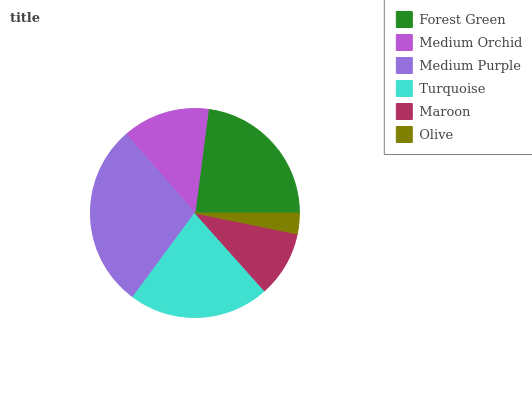Is Olive the minimum?
Answer yes or no. Yes. Is Medium Purple the maximum?
Answer yes or no. Yes. Is Medium Orchid the minimum?
Answer yes or no. No. Is Medium Orchid the maximum?
Answer yes or no. No. Is Forest Green greater than Medium Orchid?
Answer yes or no. Yes. Is Medium Orchid less than Forest Green?
Answer yes or no. Yes. Is Medium Orchid greater than Forest Green?
Answer yes or no. No. Is Forest Green less than Medium Orchid?
Answer yes or no. No. Is Turquoise the high median?
Answer yes or no. Yes. Is Medium Orchid the low median?
Answer yes or no. Yes. Is Medium Purple the high median?
Answer yes or no. No. Is Maroon the low median?
Answer yes or no. No. 